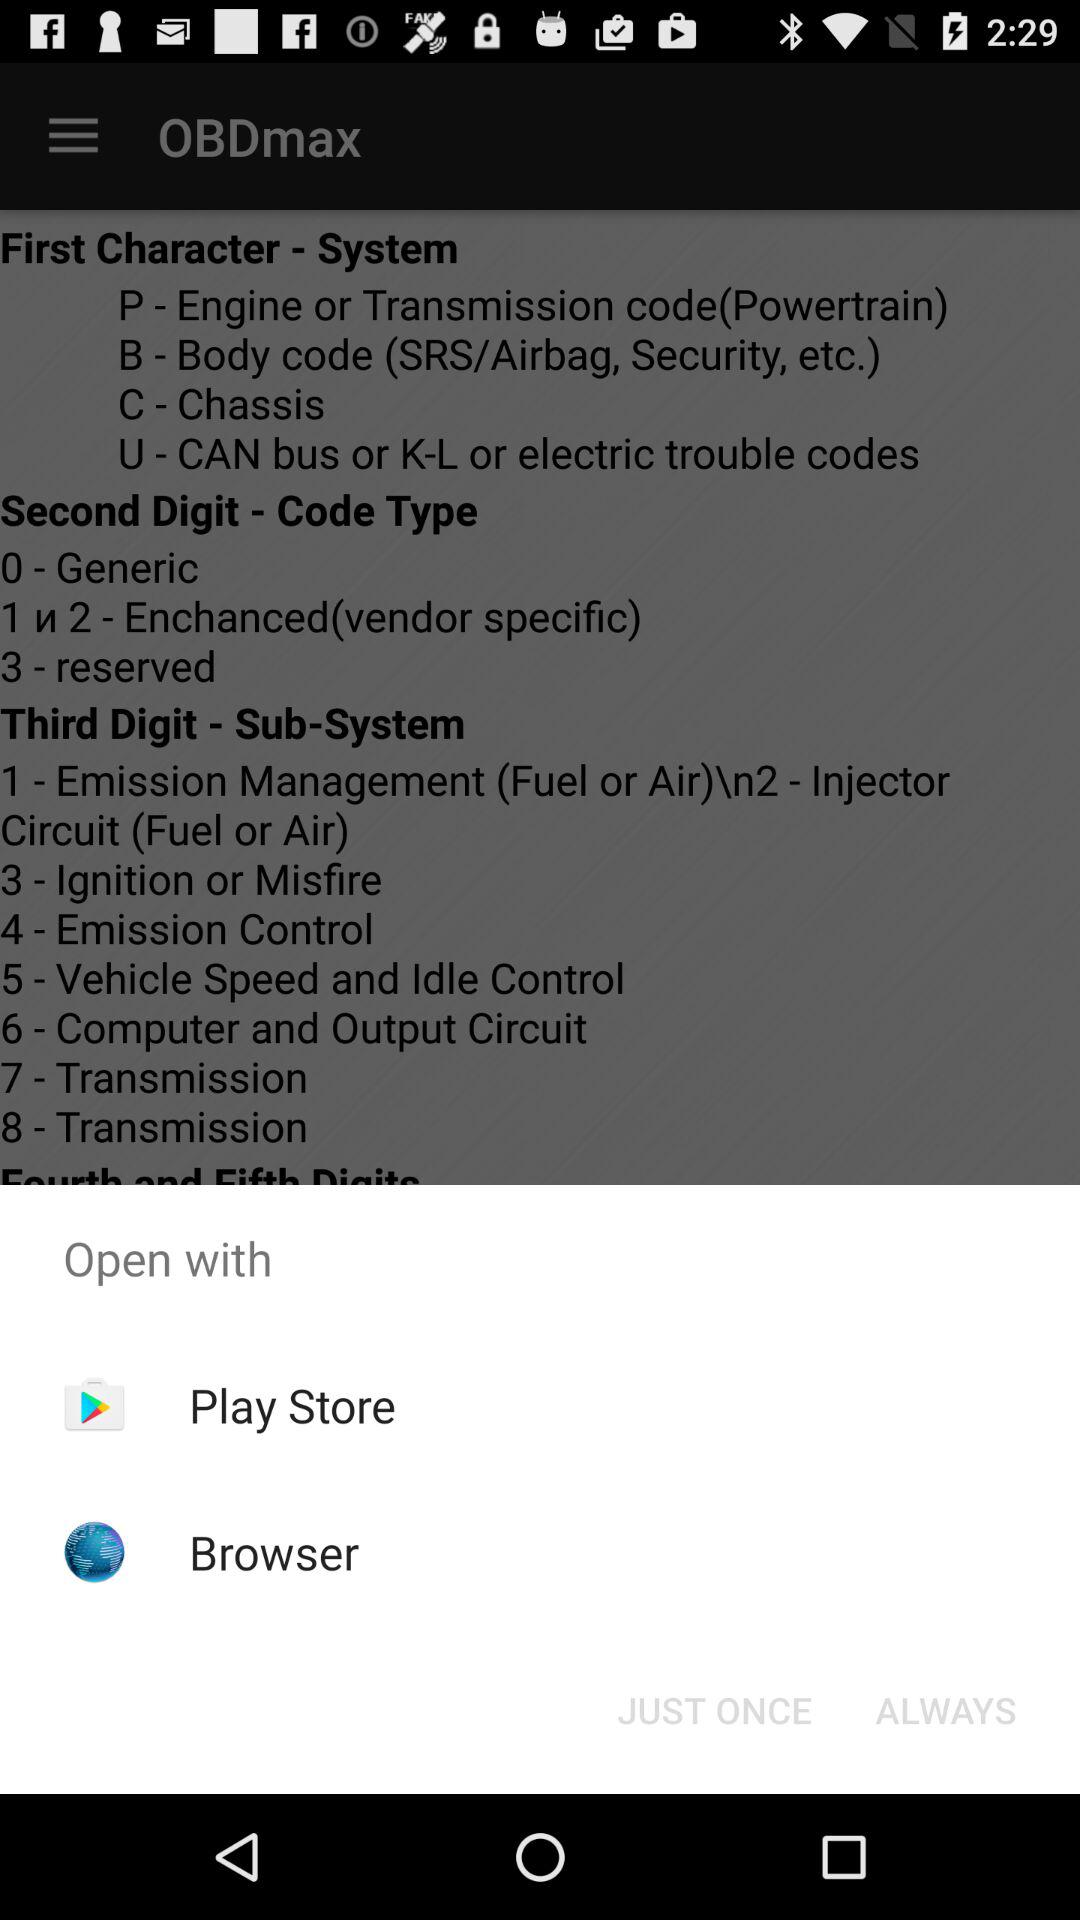With which application can we open the content? You can open the content with "Play Store" and "Browser". 